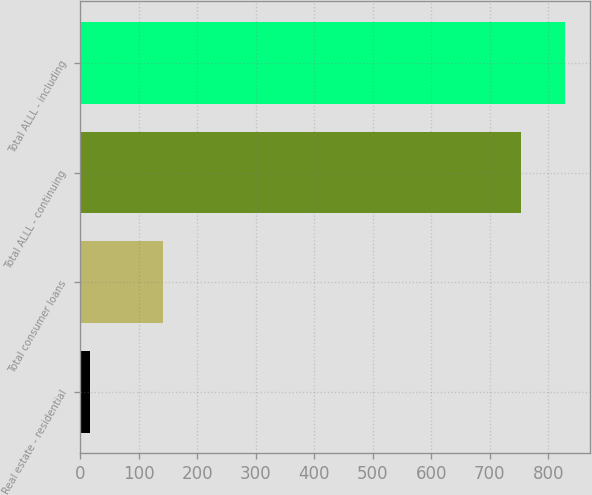Convert chart. <chart><loc_0><loc_0><loc_500><loc_500><bar_chart><fcel>Real estate - residential<fcel>Total consumer loans<fcel>Total ALLL - continuing<fcel>Total ALLL - including<nl><fcel>17<fcel>142<fcel>753<fcel>829.4<nl></chart> 